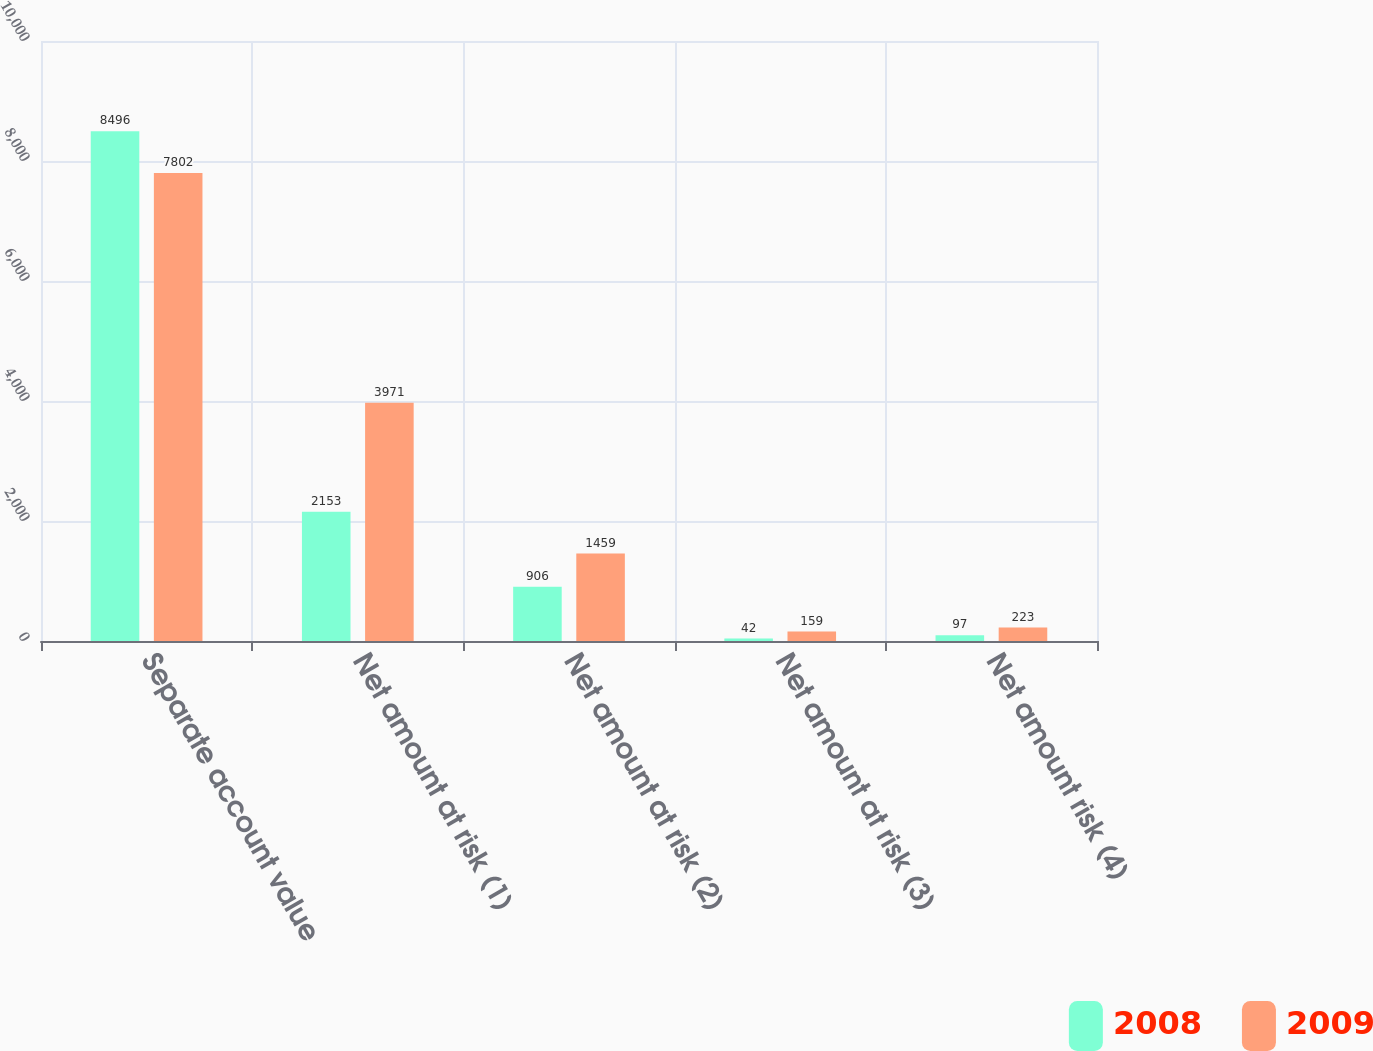<chart> <loc_0><loc_0><loc_500><loc_500><stacked_bar_chart><ecel><fcel>Separate account value<fcel>Net amount at risk (1)<fcel>Net amount at risk (2)<fcel>Net amount at risk (3)<fcel>Net amount risk (4)<nl><fcel>2008<fcel>8496<fcel>2153<fcel>906<fcel>42<fcel>97<nl><fcel>2009<fcel>7802<fcel>3971<fcel>1459<fcel>159<fcel>223<nl></chart> 